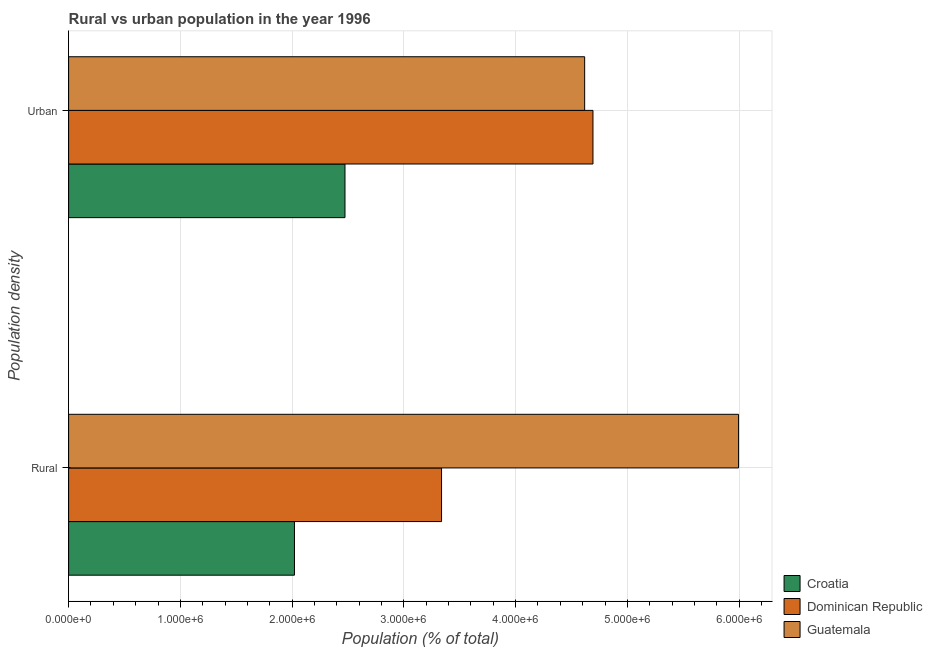How many groups of bars are there?
Your response must be concise. 2. Are the number of bars per tick equal to the number of legend labels?
Provide a succinct answer. Yes. Are the number of bars on each tick of the Y-axis equal?
Provide a succinct answer. Yes. How many bars are there on the 1st tick from the top?
Offer a very short reply. 3. How many bars are there on the 2nd tick from the bottom?
Offer a very short reply. 3. What is the label of the 1st group of bars from the top?
Your answer should be very brief. Urban. What is the urban population density in Dominican Republic?
Keep it short and to the point. 4.69e+06. Across all countries, what is the maximum urban population density?
Offer a terse response. 4.69e+06. Across all countries, what is the minimum rural population density?
Offer a very short reply. 2.02e+06. In which country was the urban population density maximum?
Offer a terse response. Dominican Republic. In which country was the urban population density minimum?
Your answer should be compact. Croatia. What is the total rural population density in the graph?
Your answer should be compact. 1.14e+07. What is the difference between the rural population density in Croatia and that in Dominican Republic?
Your answer should be compact. -1.32e+06. What is the difference between the rural population density in Croatia and the urban population density in Dominican Republic?
Your answer should be very brief. -2.67e+06. What is the average urban population density per country?
Make the answer very short. 3.93e+06. What is the difference between the urban population density and rural population density in Croatia?
Your answer should be very brief. 4.52e+05. In how many countries, is the urban population density greater than 1200000 %?
Keep it short and to the point. 3. What is the ratio of the rural population density in Croatia to that in Guatemala?
Make the answer very short. 0.34. What does the 3rd bar from the top in Rural represents?
Provide a short and direct response. Croatia. What does the 2nd bar from the bottom in Urban represents?
Keep it short and to the point. Dominican Republic. Are all the bars in the graph horizontal?
Keep it short and to the point. Yes. How many countries are there in the graph?
Keep it short and to the point. 3. What is the difference between two consecutive major ticks on the X-axis?
Offer a terse response. 1.00e+06. Are the values on the major ticks of X-axis written in scientific E-notation?
Offer a very short reply. Yes. Does the graph contain any zero values?
Offer a very short reply. No. Does the graph contain grids?
Your response must be concise. Yes. Where does the legend appear in the graph?
Make the answer very short. Bottom right. How many legend labels are there?
Offer a terse response. 3. How are the legend labels stacked?
Offer a very short reply. Vertical. What is the title of the graph?
Provide a short and direct response. Rural vs urban population in the year 1996. Does "Niger" appear as one of the legend labels in the graph?
Provide a succinct answer. No. What is the label or title of the X-axis?
Provide a short and direct response. Population (% of total). What is the label or title of the Y-axis?
Ensure brevity in your answer.  Population density. What is the Population (% of total) in Croatia in Rural?
Offer a very short reply. 2.02e+06. What is the Population (% of total) of Dominican Republic in Rural?
Your answer should be very brief. 3.34e+06. What is the Population (% of total) of Guatemala in Rural?
Your answer should be very brief. 5.99e+06. What is the Population (% of total) of Croatia in Urban?
Offer a terse response. 2.47e+06. What is the Population (% of total) in Dominican Republic in Urban?
Your answer should be very brief. 4.69e+06. What is the Population (% of total) in Guatemala in Urban?
Provide a succinct answer. 4.62e+06. Across all Population density, what is the maximum Population (% of total) in Croatia?
Your answer should be very brief. 2.47e+06. Across all Population density, what is the maximum Population (% of total) in Dominican Republic?
Your answer should be compact. 4.69e+06. Across all Population density, what is the maximum Population (% of total) of Guatemala?
Provide a succinct answer. 5.99e+06. Across all Population density, what is the minimum Population (% of total) of Croatia?
Keep it short and to the point. 2.02e+06. Across all Population density, what is the minimum Population (% of total) in Dominican Republic?
Your answer should be very brief. 3.34e+06. Across all Population density, what is the minimum Population (% of total) in Guatemala?
Your response must be concise. 4.62e+06. What is the total Population (% of total) of Croatia in the graph?
Your answer should be compact. 4.49e+06. What is the total Population (% of total) in Dominican Republic in the graph?
Provide a succinct answer. 8.03e+06. What is the total Population (% of total) in Guatemala in the graph?
Offer a terse response. 1.06e+07. What is the difference between the Population (% of total) in Croatia in Rural and that in Urban?
Offer a very short reply. -4.52e+05. What is the difference between the Population (% of total) of Dominican Republic in Rural and that in Urban?
Offer a very short reply. -1.35e+06. What is the difference between the Population (% of total) of Guatemala in Rural and that in Urban?
Ensure brevity in your answer.  1.38e+06. What is the difference between the Population (% of total) of Croatia in Rural and the Population (% of total) of Dominican Republic in Urban?
Offer a terse response. -2.67e+06. What is the difference between the Population (% of total) in Croatia in Rural and the Population (% of total) in Guatemala in Urban?
Your response must be concise. -2.60e+06. What is the difference between the Population (% of total) in Dominican Republic in Rural and the Population (% of total) in Guatemala in Urban?
Make the answer very short. -1.28e+06. What is the average Population (% of total) in Croatia per Population density?
Give a very brief answer. 2.25e+06. What is the average Population (% of total) of Dominican Republic per Population density?
Make the answer very short. 4.01e+06. What is the average Population (% of total) in Guatemala per Population density?
Your answer should be very brief. 5.31e+06. What is the difference between the Population (% of total) of Croatia and Population (% of total) of Dominican Republic in Rural?
Your response must be concise. -1.32e+06. What is the difference between the Population (% of total) in Croatia and Population (% of total) in Guatemala in Rural?
Your response must be concise. -3.97e+06. What is the difference between the Population (% of total) of Dominican Republic and Population (% of total) of Guatemala in Rural?
Provide a succinct answer. -2.66e+06. What is the difference between the Population (% of total) of Croatia and Population (% of total) of Dominican Republic in Urban?
Your answer should be very brief. -2.22e+06. What is the difference between the Population (% of total) of Croatia and Population (% of total) of Guatemala in Urban?
Your answer should be very brief. -2.14e+06. What is the difference between the Population (% of total) of Dominican Republic and Population (% of total) of Guatemala in Urban?
Your response must be concise. 7.43e+04. What is the ratio of the Population (% of total) in Croatia in Rural to that in Urban?
Keep it short and to the point. 0.82. What is the ratio of the Population (% of total) of Dominican Republic in Rural to that in Urban?
Make the answer very short. 0.71. What is the ratio of the Population (% of total) in Guatemala in Rural to that in Urban?
Your answer should be compact. 1.3. What is the difference between the highest and the second highest Population (% of total) of Croatia?
Your answer should be very brief. 4.52e+05. What is the difference between the highest and the second highest Population (% of total) of Dominican Republic?
Your answer should be very brief. 1.35e+06. What is the difference between the highest and the second highest Population (% of total) of Guatemala?
Give a very brief answer. 1.38e+06. What is the difference between the highest and the lowest Population (% of total) in Croatia?
Provide a succinct answer. 4.52e+05. What is the difference between the highest and the lowest Population (% of total) in Dominican Republic?
Your answer should be very brief. 1.35e+06. What is the difference between the highest and the lowest Population (% of total) in Guatemala?
Your answer should be compact. 1.38e+06. 